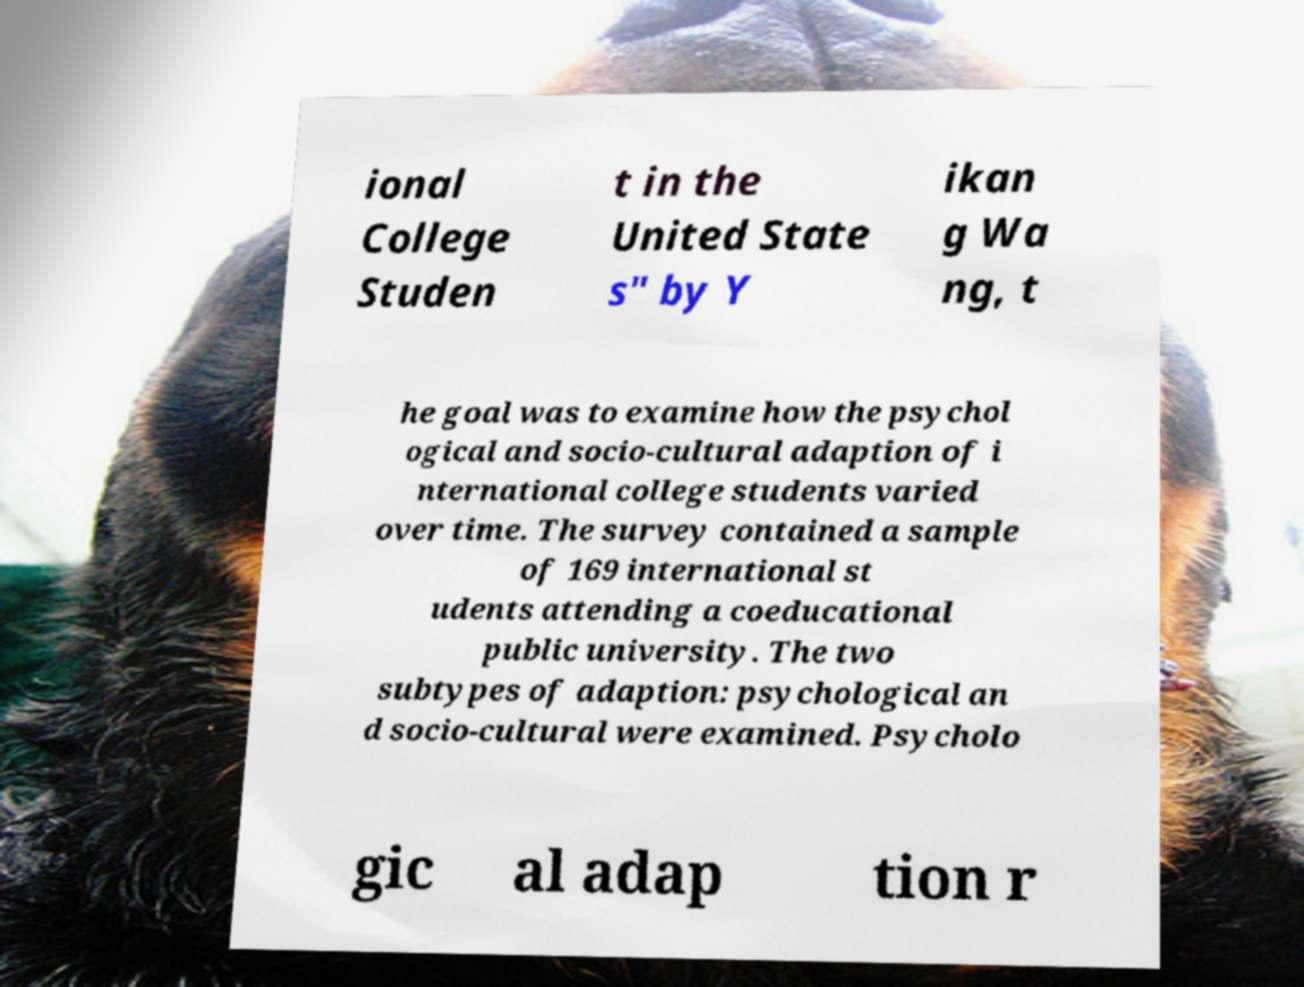Please read and relay the text visible in this image. What does it say? ional College Studen t in the United State s" by Y ikan g Wa ng, t he goal was to examine how the psychol ogical and socio-cultural adaption of i nternational college students varied over time. The survey contained a sample of 169 international st udents attending a coeducational public university. The two subtypes of adaption: psychological an d socio-cultural were examined. Psycholo gic al adap tion r 